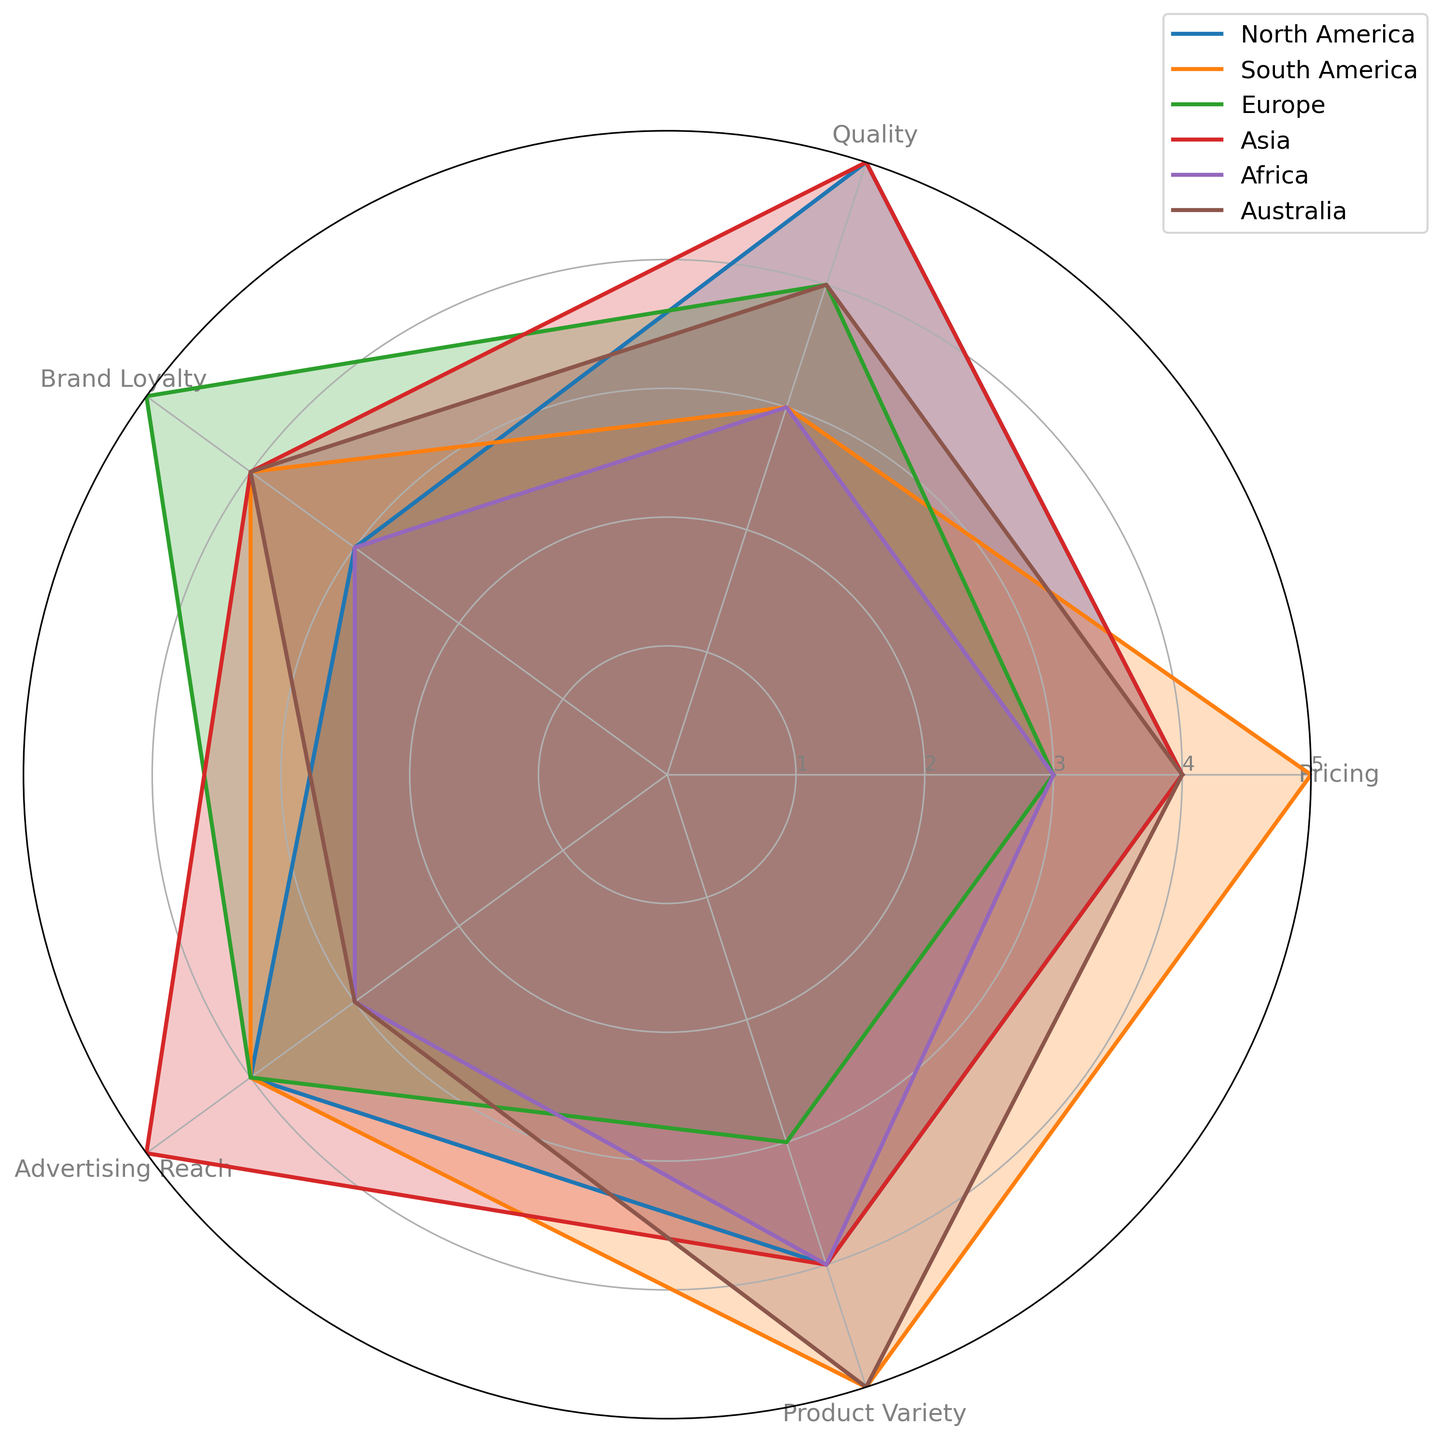Which region scores the highest in Pricing? By observing the radar chart, identify the region with the highest value on the Pricing axis. South America scores 5 in Pricing, which is the highest value.
Answer: South America Which region has the lowest average across all factors? To find the region with the lowest average score, calculate the average value for each region across all factors and compare them. Africa has averages (3+3+3+3+4)/5=3.2, which is the lowest.
Answer: Africa Compare the Advertising Reach values of Europe and Asia. Which is higher? By observing the chart, find the Advertising Reach scores of Europe and Asia. Europe scores 4, and Asia scores 5, so Asia has a higher value.
Answer: Asia How many regions score exactly 4 in Product Variety? Identify the regions that have a Product Variety score of 4. North America and Asia score 4 in Product Variety.
Answer: 2 Which two regions have equal scores in Quality? Identify the regions with the same score in the Quality axis. Both North America and Asia score 5 in Quality.
Answer: North America and Asia What is the difference in Brand Loyalty between North America and Europe? To find the difference, subtract the Brand Loyalty score of Europe from that of North America. North America has 3 and Europe has 5, so the difference is 5 - 3 = 2.
Answer: 2 What is the sum of the Product Variety scores for South America and Australia? To find the sum, add the Product Variety scores. South America scores 5 and Australia scores 5, so the total is 5 + 5 = 10.
Answer: 10 Which region has the most balanced scores (least deviation) across all factors? To determine the most balanced region, inspect the variation or spread of scores across all factors for each region. Africa has the most balanced scores, all being 3-4, as opposed to other regions.
Answer: Africa 